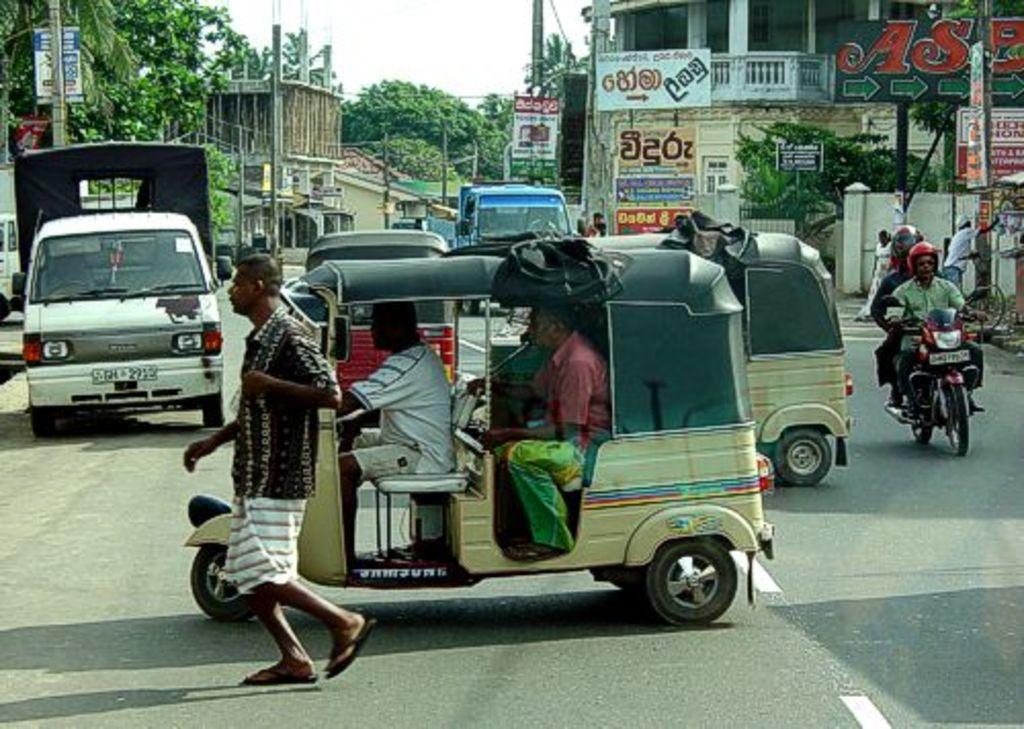Describe this image in one or two sentences. In this image, on the left there is a man, he is walking and there is a vehicle in that there are people. In the background there are vehicles, people, buildings, trees, electric poles, posters, cables, road, sky. 